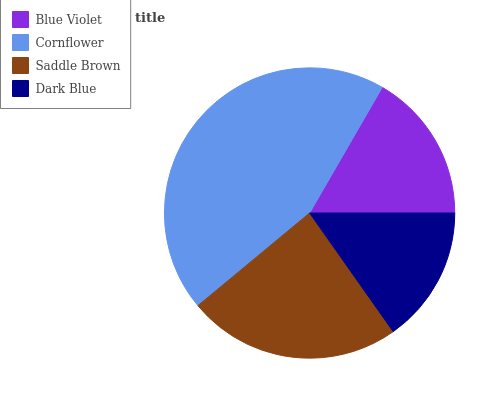Is Dark Blue the minimum?
Answer yes or no. Yes. Is Cornflower the maximum?
Answer yes or no. Yes. Is Saddle Brown the minimum?
Answer yes or no. No. Is Saddle Brown the maximum?
Answer yes or no. No. Is Cornflower greater than Saddle Brown?
Answer yes or no. Yes. Is Saddle Brown less than Cornflower?
Answer yes or no. Yes. Is Saddle Brown greater than Cornflower?
Answer yes or no. No. Is Cornflower less than Saddle Brown?
Answer yes or no. No. Is Saddle Brown the high median?
Answer yes or no. Yes. Is Blue Violet the low median?
Answer yes or no. Yes. Is Blue Violet the high median?
Answer yes or no. No. Is Cornflower the low median?
Answer yes or no. No. 